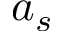Convert formula to latex. <formula><loc_0><loc_0><loc_500><loc_500>a _ { s }</formula> 